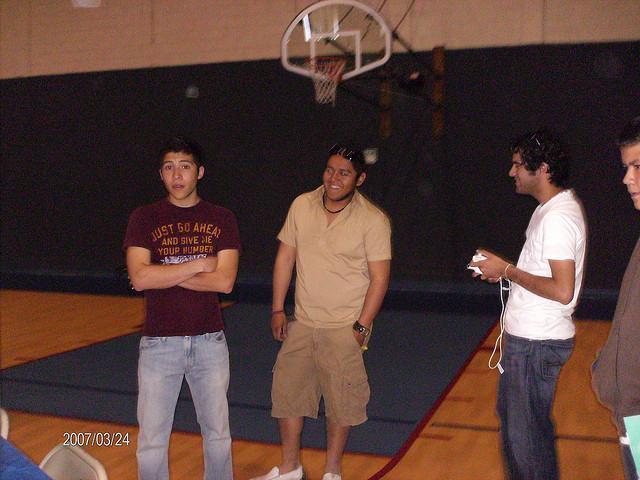How many kids are there?
Give a very brief answer. 4. How many people are wearing shorts?
Give a very brief answer. 1. How many people can be seen?
Give a very brief answer. 4. 